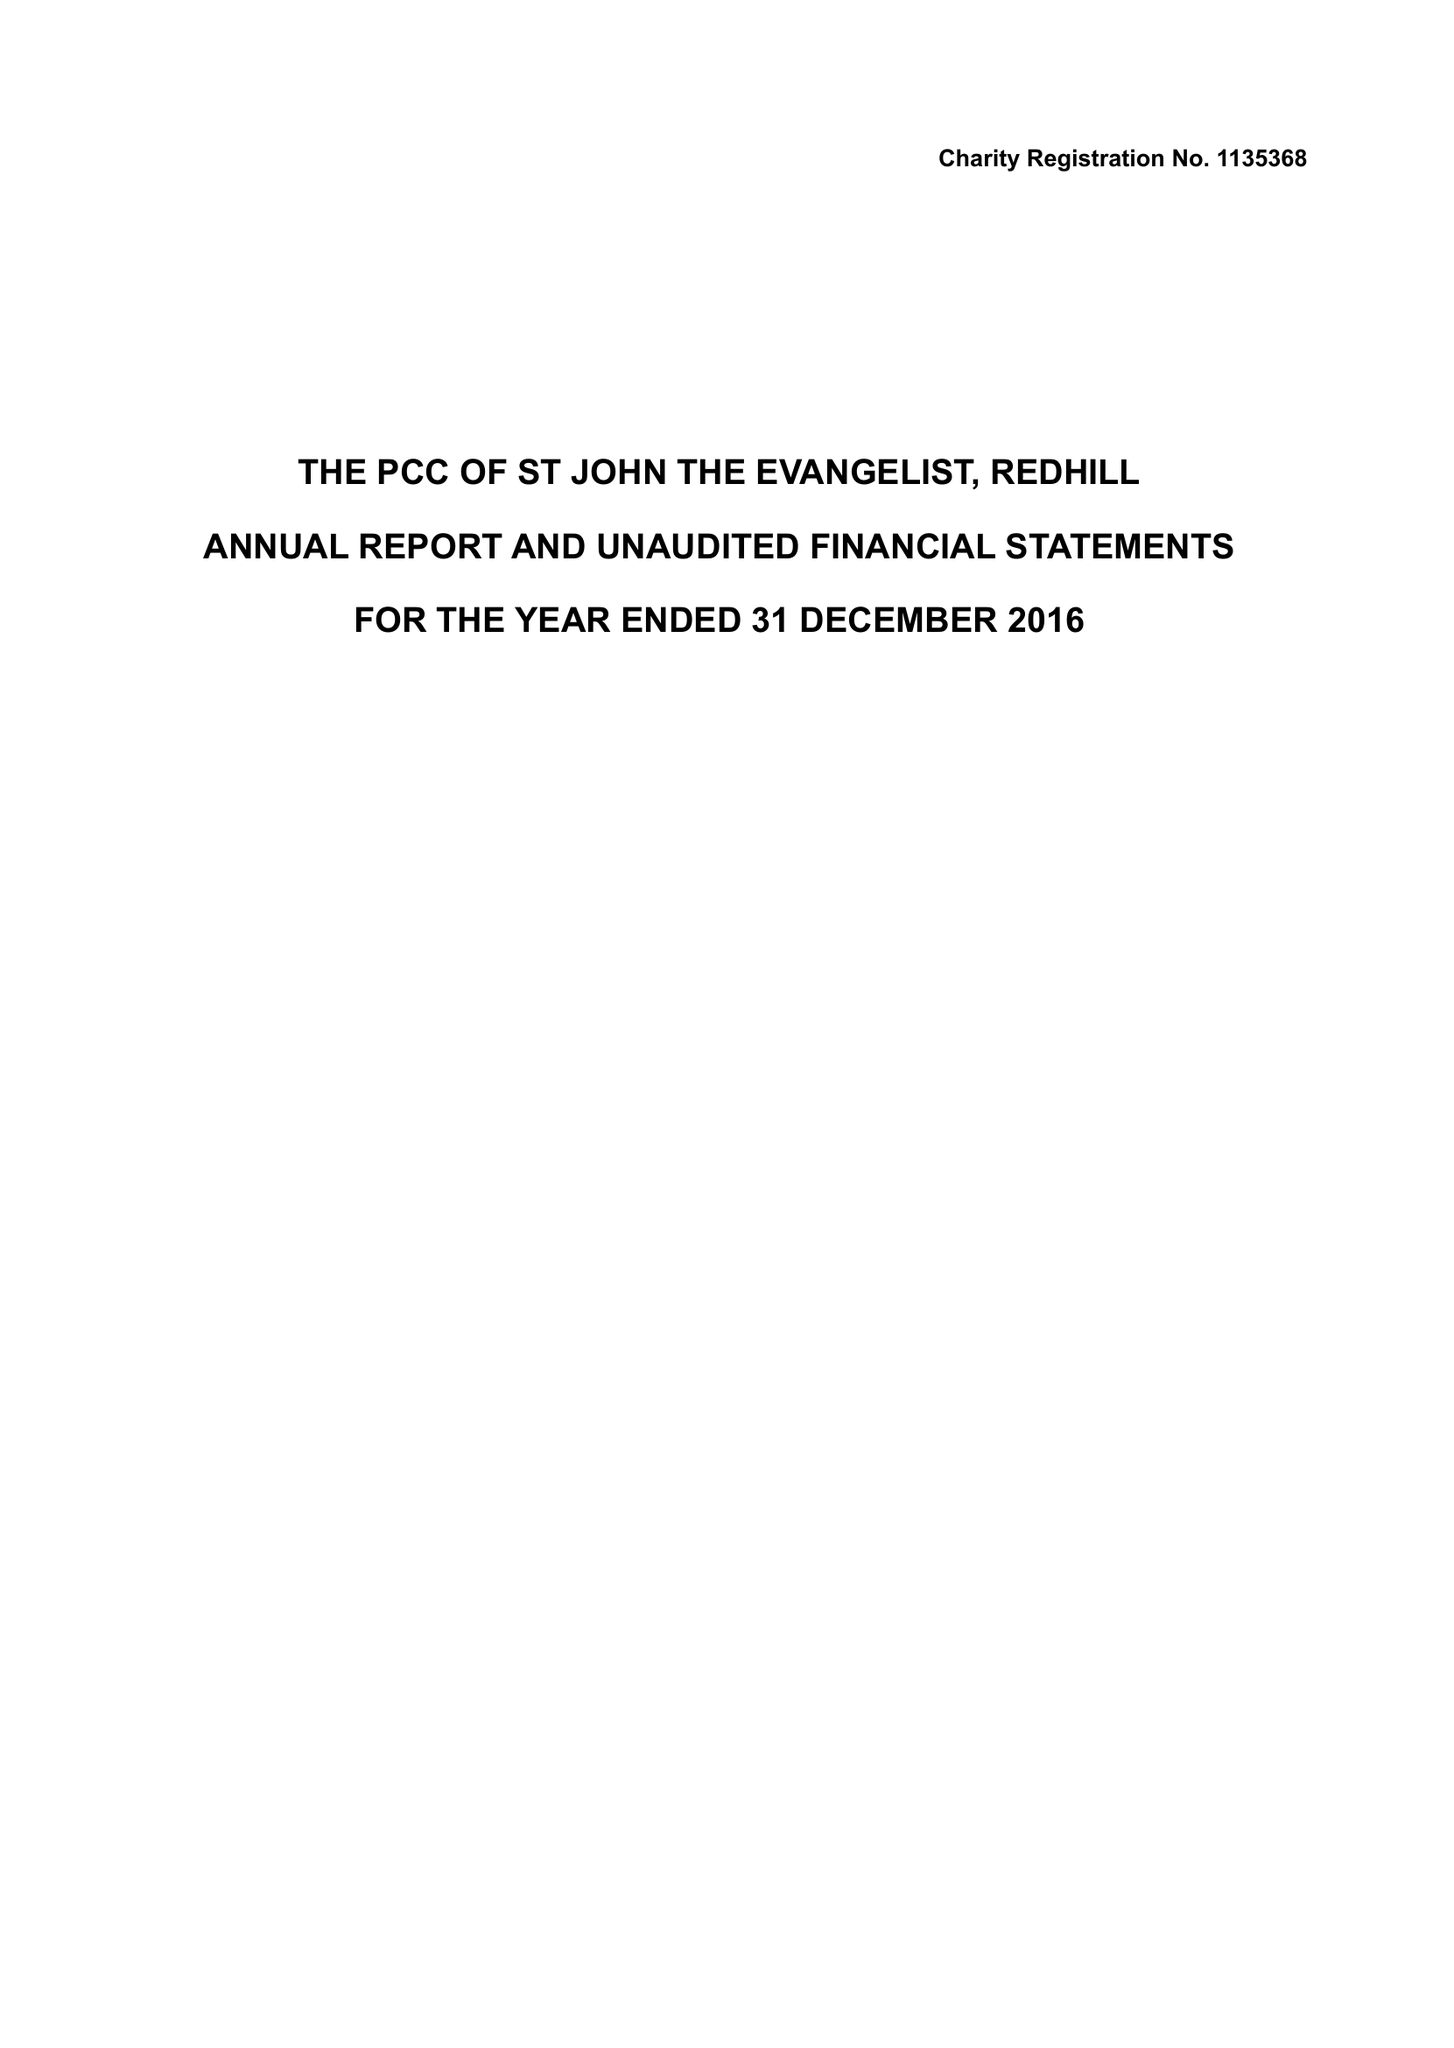What is the value for the address__postcode?
Answer the question using a single word or phrase. RH1 6QA 